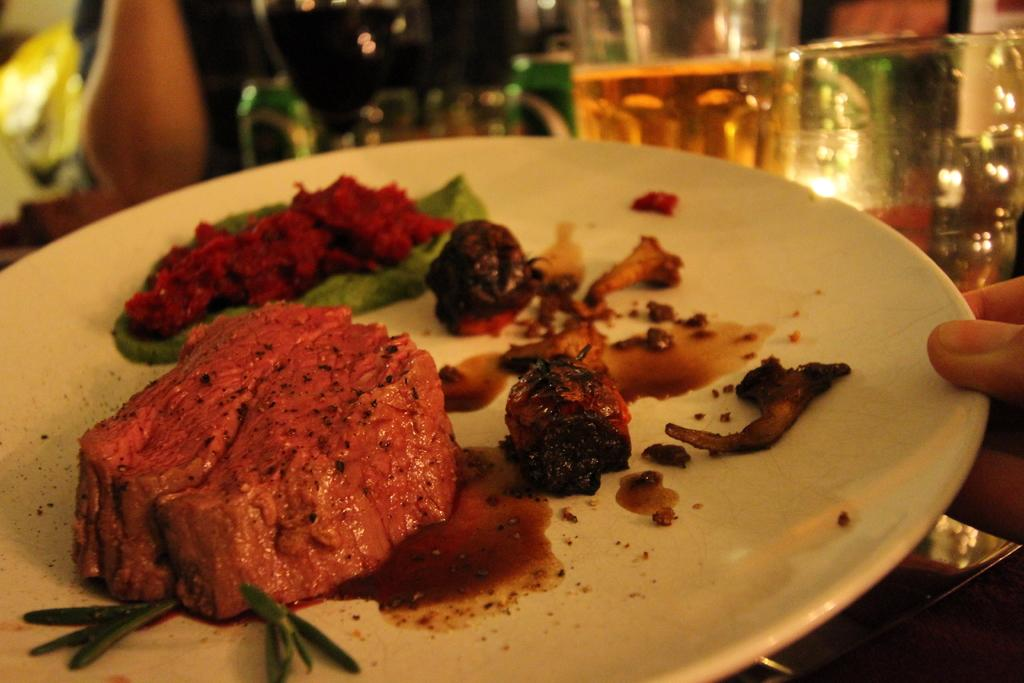What is on the plate that is visible in the image? There is a food item on the plate in the image. Who is holding the plate in the image? A person's fingers are holding the plate in the image. What else can be seen in the image besides the plate and food item? There are glasses visible in the image. Can you describe the background of the image? The background of the image appears blurry. What type of industry is depicted in the background of the image? There is no industry depicted in the background of the image; it appears blurry. Is there a curtain hanging in the background of the image? There is no curtain visible in the image; the background appears blurry. 